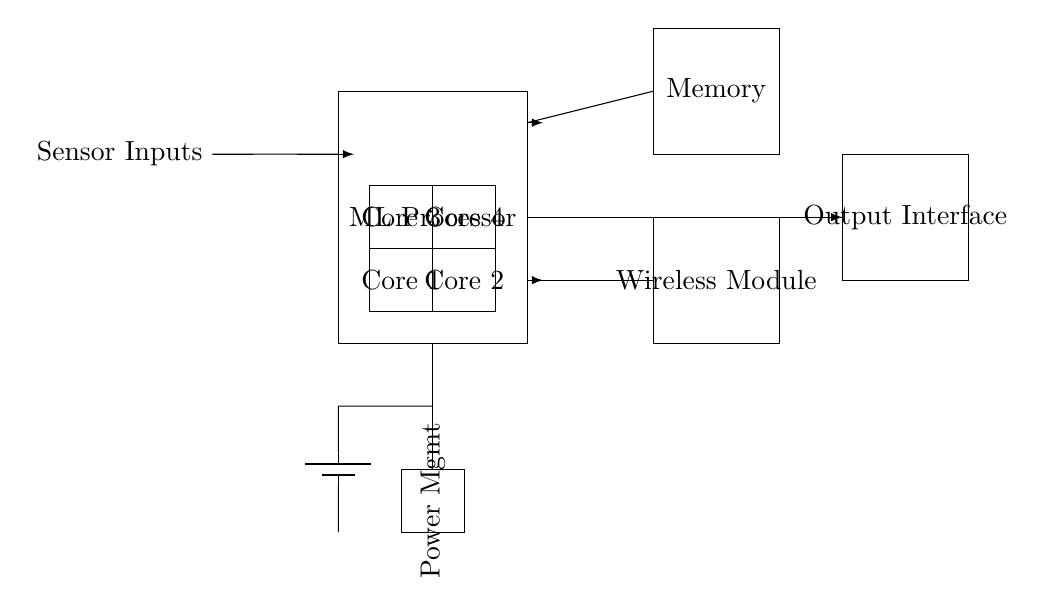What is the main component in the circuit? The main component is labeled as the "ML Processor," and it is the largest rectangle in the diagram, indicating its importance in processing.
Answer: ML Processor How many accelerator cores are present? There are four accelerator cores labeled as Core 1, Core 2, Core 3, and Core 4, which are shown as four individual rectangles within the circuit.
Answer: Four What is the role of the memory in the circuit? The memory is labeled simply as "Memory," connected to the ML Processor, indicating it serves as a storage unit for data utilized during processing tasks.
Answer: Storage unit From which component do the sensor inputs come? The sensor inputs come from the left side of the diagram, indicated by a line leading to the ML Processor, depicting the flow of data into the main processor.
Answer: ML Processor What does the power management block do? The Power Management block, indicated in the bottom left corner, regulates voltage and current supplied to the circuit to ensure efficient operation of components.
Answer: Regulates power What is the purpose of the wireless module in this circuit? The Wireless Module facilitates communication with other devices and is connected to the output interface, allowing processed data to be transmitted wirelessly.
Answer: Communication Which component provides power to the circuit? The component providing power is the battery, indicated at the bottom left of the diagram; it supplies electrical energy to the circuit.
Answer: Battery 